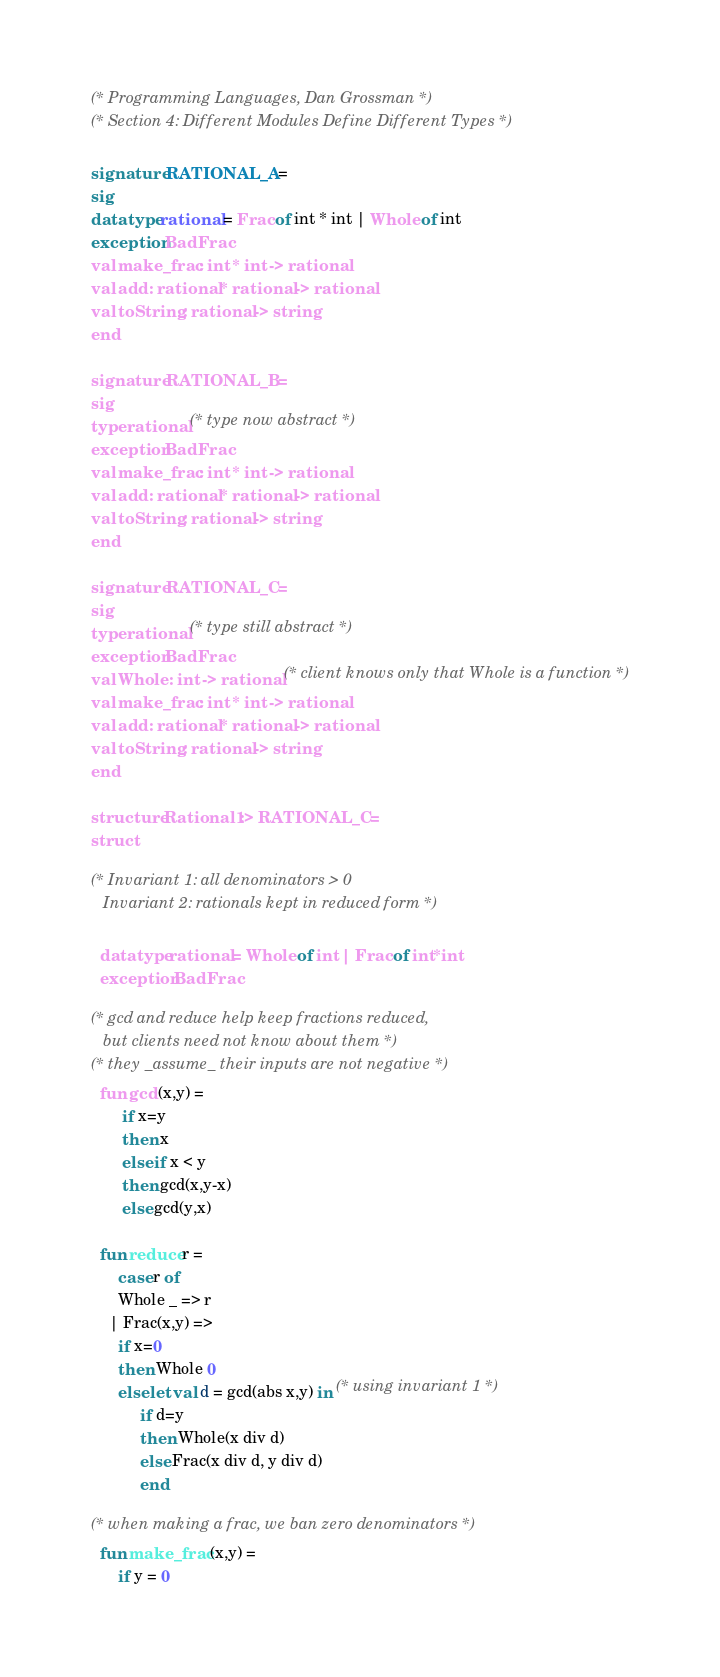<code> <loc_0><loc_0><loc_500><loc_500><_SML_>(* Programming Languages, Dan Grossman *)
(* Section 4: Different Modules Define Different Types *)

signature RATIONAL_A = 
sig
datatype rational = Frac of int * int | Whole of int
exception BadFrac
val make_frac : int * int -> rational
val add : rational * rational -> rational
val toString : rational -> string
end

signature RATIONAL_B =
sig
type rational (* type now abstract *)
exception BadFrac
val make_frac : int * int -> rational
val add : rational * rational -> rational
val toString : rational -> string
end

signature RATIONAL_C =
sig
type rational (* type still abstract *)
exception BadFrac
val Whole : int -> rational (* client knows only that Whole is a function *)
val make_frac : int * int -> rational
val add : rational * rational -> rational
val toString : rational -> string
end 

structure Rational1 :> RATIONAL_C = 
struct

(* Invariant 1: all denominators > 0
   Invariant 2: rationals kept in reduced form *)

  datatype rational = Whole of int | Frac of int*int
  exception BadFrac

(* gcd and reduce help keep fractions reduced, 
   but clients need not know about them *)
(* they _assume_ their inputs are not negative *)
  fun gcd (x,y) =
       if x=y
       then x
       else if x < y
       then gcd(x,y-x)
       else gcd(y,x)

  fun reduce r =
      case r of
	  Whole _ => r
	| Frac(x,y) => 
	  if x=0
	  then Whole 0
	  else let val d = gcd(abs x,y) in (* using invariant 1 *)
		   if d=y 
		   then Whole(x div d) 
		   else Frac(x div d, y div d) 
	       end

(* when making a frac, we ban zero denominators *)
  fun make_frac (x,y) =
      if y = 0</code> 